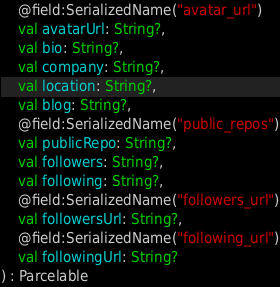<code> <loc_0><loc_0><loc_500><loc_500><_Kotlin_>    @field:SerializedName("avatar_url")
    val avatarUrl: String?,
    val bio: String?,
    val company: String?,
    val location: String?,
    val blog: String?,
    @field:SerializedName("public_repos")
    val publicRepo: String?,
    val followers: String?,
    val following: String?,
    @field:SerializedName("followers_url")
    val followersUrl: String?,
    @field:SerializedName("following_url")
    val followingUrl: String?
) : Parcelable</code> 